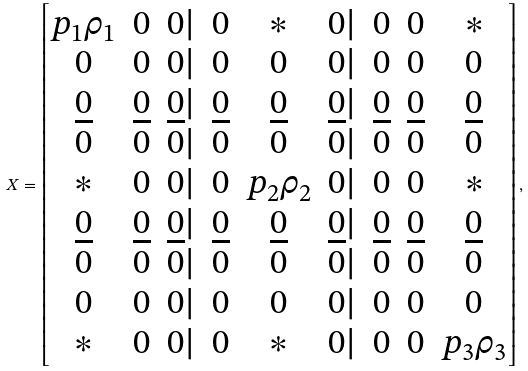Convert formula to latex. <formula><loc_0><loc_0><loc_500><loc_500>X = \begin{bmatrix} p _ { 1 } \rho _ { 1 } & 0 & 0 | & 0 & * & 0 | & 0 & 0 & * \\ 0 & 0 & 0 | & 0 & 0 & 0 | & 0 & 0 & 0 \\ \underline { 0 } & \underline { 0 } & \underline { 0 } | & \underline { 0 } & \underline { 0 } & \underline { 0 } | & \underline { 0 } & \underline { 0 } & \underline { 0 } \\ 0 & 0 & 0 | & 0 & 0 & 0 | & 0 & 0 & 0 \\ * & 0 & 0 | & 0 & p _ { 2 } \rho _ { 2 } & 0 | & 0 & 0 & * \\ \underline { 0 } & \underline { 0 } & \underline { 0 } | & \underline { 0 } & \underline { 0 } & \underline { 0 } | & \underline { 0 } & \underline { 0 } & \underline { 0 } \\ 0 & 0 & 0 | & 0 & 0 & 0 | & 0 & 0 & 0 \\ 0 & 0 & 0 | & 0 & 0 & 0 | & 0 & 0 & 0 \\ * & 0 & 0 | & 0 & * & 0 | & 0 & 0 & p _ { 3 } \rho _ { 3 } \\ \end{bmatrix} ,</formula> 